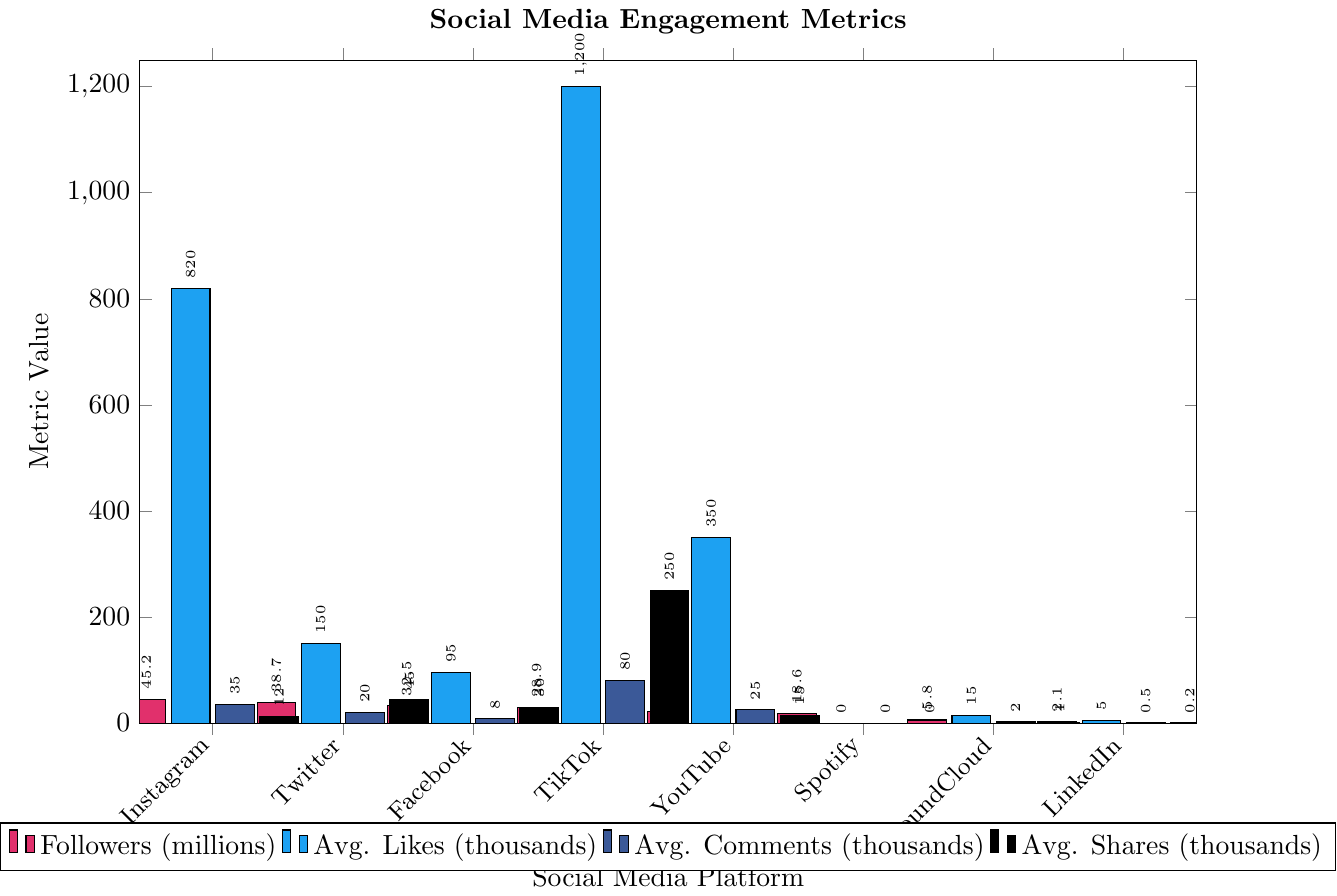What's the total number of followers across all platforms? Add the followers for each platform: 45.2 (Instagram) + 38.7 (Twitter) + 32.5 (Facebook) + 28.9 (TikTok) + 22.3 (YouTube) + 18.6 (Spotify) + 5.8 (SoundCloud) + 2.1 (LinkedIn) = 194.1 million
Answer: 194.1 million Which platform has the highest average likes per post? Compare the average likes per post for each platform: 820 (Instagram), 150 (Twitter), 95 (Facebook), 1200 (TikTok), 350 (YouTube), 0 (Spotify), 15 (SoundCloud), 5 (LinkedIn). TikTok has the highest average likes per post at 1200.
Answer: TikTok Is the number of average comments per post on Instagram greater than on YouTube? Look at the average comments per post for Instagram (35) and YouTube (25). Compare the two values. 35 (Instagram) > 25 (YouTube).
Answer: Yes Which two platforms have the closest number of average shares per post? Compare the average shares per post: 12 (Instagram), 45 (Twitter), 30 (Facebook), 250 (TikTok), 15 (YouTube), 0 (Spotify), 1 (SoundCloud), 0.2 (LinkedIn). Instagram (12) and YouTube (15) are the closest.
Answer: Instagram and YouTube What’s the combined average number of comments per post for Twitter and Facebook? Add the average comments per post for Twitter (20) and for Facebook (8): 20 + 8 = 28
Answer: 28 On which platform are average shares per post more than average comments per post? Compare average shares per post and average comments per post for each platform: Instagram (12 < 35), Twitter (45 > 20), Facebook (30 > 8), TikTok (250 > 80), YouTube (15 < 25), Spotify (0 = 0), SoundCloud (1 < 2), LinkedIn (0.2 < 0.5). Twitter and TikTok have more average shares than comments.
Answer: Twitter and TikTok Which platform has the lowest followers count, and what is the count? Compare the followers count for each platform: 45.2 (Instagram), 38.7 (Twitter), 32.5 (Facebook), 28.9 (TikTok), 22.3 (YouTube), 18.6 (Spotify), 5.8 (SoundCloud), 2.1 (LinkedIn). LinkedIn has the lowest number of followers at 2.1 million.
Answer: LinkedIn, 2.1 million 